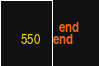Convert code to text. <code><loc_0><loc_0><loc_500><loc_500><_Ruby_>  end
end
</code> 